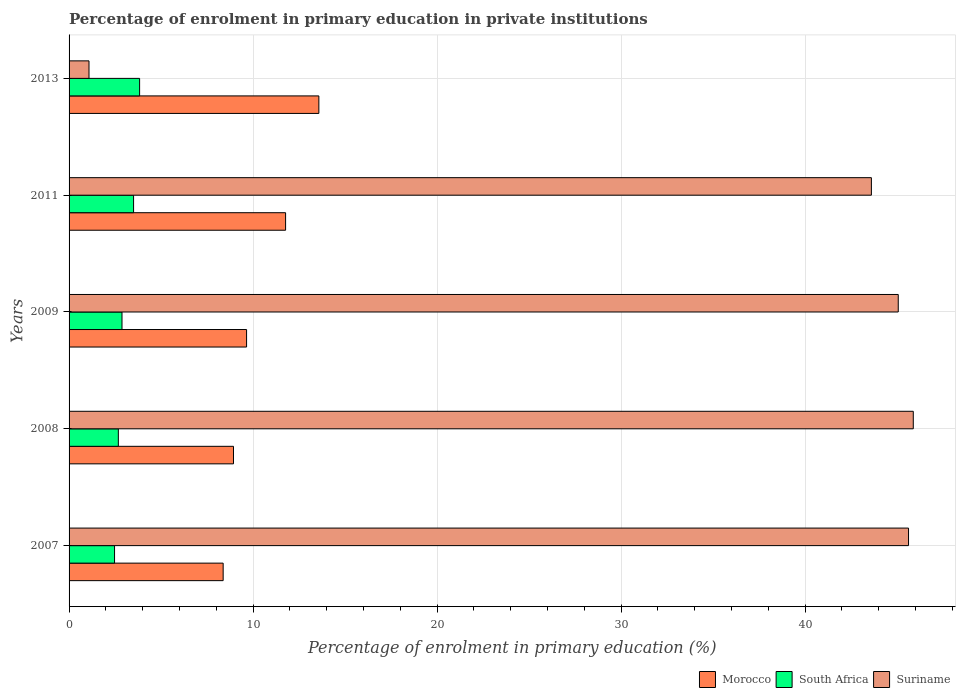Are the number of bars on each tick of the Y-axis equal?
Provide a short and direct response. Yes. How many bars are there on the 4th tick from the bottom?
Your answer should be compact. 3. What is the label of the 1st group of bars from the top?
Keep it short and to the point. 2013. What is the percentage of enrolment in primary education in Morocco in 2007?
Offer a very short reply. 8.37. Across all years, what is the maximum percentage of enrolment in primary education in Morocco?
Offer a very short reply. 13.58. Across all years, what is the minimum percentage of enrolment in primary education in South Africa?
Your answer should be compact. 2.47. What is the total percentage of enrolment in primary education in Suriname in the graph?
Keep it short and to the point. 181.26. What is the difference between the percentage of enrolment in primary education in Morocco in 2009 and that in 2013?
Ensure brevity in your answer.  -3.93. What is the difference between the percentage of enrolment in primary education in Morocco in 2007 and the percentage of enrolment in primary education in South Africa in 2013?
Offer a terse response. 4.54. What is the average percentage of enrolment in primary education in Suriname per year?
Offer a terse response. 36.25. In the year 2011, what is the difference between the percentage of enrolment in primary education in South Africa and percentage of enrolment in primary education in Morocco?
Provide a short and direct response. -8.26. What is the ratio of the percentage of enrolment in primary education in South Africa in 2011 to that in 2013?
Keep it short and to the point. 0.91. Is the percentage of enrolment in primary education in Morocco in 2007 less than that in 2011?
Offer a terse response. Yes. What is the difference between the highest and the second highest percentage of enrolment in primary education in South Africa?
Offer a very short reply. 0.33. What is the difference between the highest and the lowest percentage of enrolment in primary education in Suriname?
Offer a terse response. 44.8. Is the sum of the percentage of enrolment in primary education in Suriname in 2007 and 2011 greater than the maximum percentage of enrolment in primary education in South Africa across all years?
Provide a short and direct response. Yes. What does the 3rd bar from the top in 2013 represents?
Your response must be concise. Morocco. What does the 2nd bar from the bottom in 2007 represents?
Your answer should be compact. South Africa. What is the difference between two consecutive major ticks on the X-axis?
Provide a succinct answer. 10. Are the values on the major ticks of X-axis written in scientific E-notation?
Your response must be concise. No. Does the graph contain grids?
Offer a very short reply. Yes. How many legend labels are there?
Your answer should be compact. 3. What is the title of the graph?
Ensure brevity in your answer.  Percentage of enrolment in primary education in private institutions. What is the label or title of the X-axis?
Your answer should be very brief. Percentage of enrolment in primary education (%). What is the label or title of the Y-axis?
Your answer should be very brief. Years. What is the Percentage of enrolment in primary education (%) in Morocco in 2007?
Offer a terse response. 8.37. What is the Percentage of enrolment in primary education (%) of South Africa in 2007?
Your response must be concise. 2.47. What is the Percentage of enrolment in primary education (%) in Suriname in 2007?
Provide a succinct answer. 45.62. What is the Percentage of enrolment in primary education (%) in Morocco in 2008?
Offer a terse response. 8.94. What is the Percentage of enrolment in primary education (%) of South Africa in 2008?
Keep it short and to the point. 2.68. What is the Percentage of enrolment in primary education (%) in Suriname in 2008?
Provide a succinct answer. 45.88. What is the Percentage of enrolment in primary education (%) in Morocco in 2009?
Provide a short and direct response. 9.65. What is the Percentage of enrolment in primary education (%) in South Africa in 2009?
Your answer should be very brief. 2.88. What is the Percentage of enrolment in primary education (%) in Suriname in 2009?
Offer a terse response. 45.06. What is the Percentage of enrolment in primary education (%) of Morocco in 2011?
Your response must be concise. 11.77. What is the Percentage of enrolment in primary education (%) in South Africa in 2011?
Ensure brevity in your answer.  3.51. What is the Percentage of enrolment in primary education (%) of Suriname in 2011?
Your answer should be compact. 43.6. What is the Percentage of enrolment in primary education (%) in Morocco in 2013?
Your answer should be compact. 13.58. What is the Percentage of enrolment in primary education (%) in South Africa in 2013?
Your answer should be very brief. 3.83. What is the Percentage of enrolment in primary education (%) in Suriname in 2013?
Make the answer very short. 1.08. Across all years, what is the maximum Percentage of enrolment in primary education (%) in Morocco?
Provide a succinct answer. 13.58. Across all years, what is the maximum Percentage of enrolment in primary education (%) in South Africa?
Offer a very short reply. 3.83. Across all years, what is the maximum Percentage of enrolment in primary education (%) in Suriname?
Make the answer very short. 45.88. Across all years, what is the minimum Percentage of enrolment in primary education (%) in Morocco?
Give a very brief answer. 8.37. Across all years, what is the minimum Percentage of enrolment in primary education (%) in South Africa?
Your answer should be very brief. 2.47. Across all years, what is the minimum Percentage of enrolment in primary education (%) of Suriname?
Keep it short and to the point. 1.08. What is the total Percentage of enrolment in primary education (%) of Morocco in the graph?
Offer a very short reply. 52.3. What is the total Percentage of enrolment in primary education (%) of South Africa in the graph?
Your answer should be compact. 15.37. What is the total Percentage of enrolment in primary education (%) in Suriname in the graph?
Give a very brief answer. 181.26. What is the difference between the Percentage of enrolment in primary education (%) in Morocco in 2007 and that in 2008?
Give a very brief answer. -0.56. What is the difference between the Percentage of enrolment in primary education (%) of South Africa in 2007 and that in 2008?
Offer a terse response. -0.21. What is the difference between the Percentage of enrolment in primary education (%) of Suriname in 2007 and that in 2008?
Your answer should be compact. -0.26. What is the difference between the Percentage of enrolment in primary education (%) in Morocco in 2007 and that in 2009?
Your answer should be very brief. -1.27. What is the difference between the Percentage of enrolment in primary education (%) in South Africa in 2007 and that in 2009?
Provide a succinct answer. -0.4. What is the difference between the Percentage of enrolment in primary education (%) in Suriname in 2007 and that in 2009?
Your answer should be very brief. 0.56. What is the difference between the Percentage of enrolment in primary education (%) in Morocco in 2007 and that in 2011?
Provide a short and direct response. -3.39. What is the difference between the Percentage of enrolment in primary education (%) in South Africa in 2007 and that in 2011?
Ensure brevity in your answer.  -1.03. What is the difference between the Percentage of enrolment in primary education (%) in Suriname in 2007 and that in 2011?
Give a very brief answer. 2.02. What is the difference between the Percentage of enrolment in primary education (%) of Morocco in 2007 and that in 2013?
Your answer should be compact. -5.2. What is the difference between the Percentage of enrolment in primary education (%) of South Africa in 2007 and that in 2013?
Offer a terse response. -1.36. What is the difference between the Percentage of enrolment in primary education (%) in Suriname in 2007 and that in 2013?
Your answer should be very brief. 44.54. What is the difference between the Percentage of enrolment in primary education (%) of Morocco in 2008 and that in 2009?
Keep it short and to the point. -0.71. What is the difference between the Percentage of enrolment in primary education (%) in South Africa in 2008 and that in 2009?
Provide a short and direct response. -0.2. What is the difference between the Percentage of enrolment in primary education (%) in Suriname in 2008 and that in 2009?
Provide a short and direct response. 0.82. What is the difference between the Percentage of enrolment in primary education (%) of Morocco in 2008 and that in 2011?
Your answer should be very brief. -2.83. What is the difference between the Percentage of enrolment in primary education (%) of South Africa in 2008 and that in 2011?
Give a very brief answer. -0.83. What is the difference between the Percentage of enrolment in primary education (%) of Suriname in 2008 and that in 2011?
Ensure brevity in your answer.  2.28. What is the difference between the Percentage of enrolment in primary education (%) of Morocco in 2008 and that in 2013?
Ensure brevity in your answer.  -4.64. What is the difference between the Percentage of enrolment in primary education (%) in South Africa in 2008 and that in 2013?
Keep it short and to the point. -1.16. What is the difference between the Percentage of enrolment in primary education (%) of Suriname in 2008 and that in 2013?
Offer a very short reply. 44.8. What is the difference between the Percentage of enrolment in primary education (%) in Morocco in 2009 and that in 2011?
Offer a terse response. -2.12. What is the difference between the Percentage of enrolment in primary education (%) in South Africa in 2009 and that in 2011?
Offer a terse response. -0.63. What is the difference between the Percentage of enrolment in primary education (%) in Suriname in 2009 and that in 2011?
Ensure brevity in your answer.  1.46. What is the difference between the Percentage of enrolment in primary education (%) in Morocco in 2009 and that in 2013?
Your answer should be compact. -3.93. What is the difference between the Percentage of enrolment in primary education (%) of South Africa in 2009 and that in 2013?
Make the answer very short. -0.96. What is the difference between the Percentage of enrolment in primary education (%) of Suriname in 2009 and that in 2013?
Your answer should be very brief. 43.98. What is the difference between the Percentage of enrolment in primary education (%) of Morocco in 2011 and that in 2013?
Ensure brevity in your answer.  -1.81. What is the difference between the Percentage of enrolment in primary education (%) of South Africa in 2011 and that in 2013?
Your answer should be very brief. -0.33. What is the difference between the Percentage of enrolment in primary education (%) in Suriname in 2011 and that in 2013?
Offer a very short reply. 42.52. What is the difference between the Percentage of enrolment in primary education (%) of Morocco in 2007 and the Percentage of enrolment in primary education (%) of South Africa in 2008?
Keep it short and to the point. 5.7. What is the difference between the Percentage of enrolment in primary education (%) of Morocco in 2007 and the Percentage of enrolment in primary education (%) of Suriname in 2008?
Your answer should be compact. -37.51. What is the difference between the Percentage of enrolment in primary education (%) in South Africa in 2007 and the Percentage of enrolment in primary education (%) in Suriname in 2008?
Ensure brevity in your answer.  -43.41. What is the difference between the Percentage of enrolment in primary education (%) in Morocco in 2007 and the Percentage of enrolment in primary education (%) in South Africa in 2009?
Your response must be concise. 5.5. What is the difference between the Percentage of enrolment in primary education (%) of Morocco in 2007 and the Percentage of enrolment in primary education (%) of Suriname in 2009?
Make the answer very short. -36.69. What is the difference between the Percentage of enrolment in primary education (%) in South Africa in 2007 and the Percentage of enrolment in primary education (%) in Suriname in 2009?
Make the answer very short. -42.59. What is the difference between the Percentage of enrolment in primary education (%) in Morocco in 2007 and the Percentage of enrolment in primary education (%) in South Africa in 2011?
Your response must be concise. 4.87. What is the difference between the Percentage of enrolment in primary education (%) of Morocco in 2007 and the Percentage of enrolment in primary education (%) of Suriname in 2011?
Ensure brevity in your answer.  -35.23. What is the difference between the Percentage of enrolment in primary education (%) in South Africa in 2007 and the Percentage of enrolment in primary education (%) in Suriname in 2011?
Give a very brief answer. -41.13. What is the difference between the Percentage of enrolment in primary education (%) in Morocco in 2007 and the Percentage of enrolment in primary education (%) in South Africa in 2013?
Make the answer very short. 4.54. What is the difference between the Percentage of enrolment in primary education (%) of Morocco in 2007 and the Percentage of enrolment in primary education (%) of Suriname in 2013?
Your response must be concise. 7.29. What is the difference between the Percentage of enrolment in primary education (%) of South Africa in 2007 and the Percentage of enrolment in primary education (%) of Suriname in 2013?
Give a very brief answer. 1.39. What is the difference between the Percentage of enrolment in primary education (%) in Morocco in 2008 and the Percentage of enrolment in primary education (%) in South Africa in 2009?
Offer a very short reply. 6.06. What is the difference between the Percentage of enrolment in primary education (%) in Morocco in 2008 and the Percentage of enrolment in primary education (%) in Suriname in 2009?
Make the answer very short. -36.13. What is the difference between the Percentage of enrolment in primary education (%) in South Africa in 2008 and the Percentage of enrolment in primary education (%) in Suriname in 2009?
Provide a succinct answer. -42.39. What is the difference between the Percentage of enrolment in primary education (%) in Morocco in 2008 and the Percentage of enrolment in primary education (%) in South Africa in 2011?
Provide a short and direct response. 5.43. What is the difference between the Percentage of enrolment in primary education (%) in Morocco in 2008 and the Percentage of enrolment in primary education (%) in Suriname in 2011?
Make the answer very short. -34.67. What is the difference between the Percentage of enrolment in primary education (%) in South Africa in 2008 and the Percentage of enrolment in primary education (%) in Suriname in 2011?
Provide a short and direct response. -40.93. What is the difference between the Percentage of enrolment in primary education (%) in Morocco in 2008 and the Percentage of enrolment in primary education (%) in South Africa in 2013?
Keep it short and to the point. 5.1. What is the difference between the Percentage of enrolment in primary education (%) in Morocco in 2008 and the Percentage of enrolment in primary education (%) in Suriname in 2013?
Your answer should be very brief. 7.85. What is the difference between the Percentage of enrolment in primary education (%) of South Africa in 2008 and the Percentage of enrolment in primary education (%) of Suriname in 2013?
Provide a succinct answer. 1.59. What is the difference between the Percentage of enrolment in primary education (%) of Morocco in 2009 and the Percentage of enrolment in primary education (%) of South Africa in 2011?
Make the answer very short. 6.14. What is the difference between the Percentage of enrolment in primary education (%) of Morocco in 2009 and the Percentage of enrolment in primary education (%) of Suriname in 2011?
Offer a very short reply. -33.96. What is the difference between the Percentage of enrolment in primary education (%) of South Africa in 2009 and the Percentage of enrolment in primary education (%) of Suriname in 2011?
Offer a terse response. -40.73. What is the difference between the Percentage of enrolment in primary education (%) of Morocco in 2009 and the Percentage of enrolment in primary education (%) of South Africa in 2013?
Ensure brevity in your answer.  5.81. What is the difference between the Percentage of enrolment in primary education (%) in Morocco in 2009 and the Percentage of enrolment in primary education (%) in Suriname in 2013?
Offer a terse response. 8.56. What is the difference between the Percentage of enrolment in primary education (%) in South Africa in 2009 and the Percentage of enrolment in primary education (%) in Suriname in 2013?
Your response must be concise. 1.79. What is the difference between the Percentage of enrolment in primary education (%) of Morocco in 2011 and the Percentage of enrolment in primary education (%) of South Africa in 2013?
Give a very brief answer. 7.93. What is the difference between the Percentage of enrolment in primary education (%) in Morocco in 2011 and the Percentage of enrolment in primary education (%) in Suriname in 2013?
Your answer should be very brief. 10.68. What is the difference between the Percentage of enrolment in primary education (%) of South Africa in 2011 and the Percentage of enrolment in primary education (%) of Suriname in 2013?
Keep it short and to the point. 2.42. What is the average Percentage of enrolment in primary education (%) in Morocco per year?
Ensure brevity in your answer.  10.46. What is the average Percentage of enrolment in primary education (%) in South Africa per year?
Offer a terse response. 3.07. What is the average Percentage of enrolment in primary education (%) in Suriname per year?
Your answer should be compact. 36.25. In the year 2007, what is the difference between the Percentage of enrolment in primary education (%) of Morocco and Percentage of enrolment in primary education (%) of South Africa?
Provide a short and direct response. 5.9. In the year 2007, what is the difference between the Percentage of enrolment in primary education (%) in Morocco and Percentage of enrolment in primary education (%) in Suriname?
Offer a terse response. -37.25. In the year 2007, what is the difference between the Percentage of enrolment in primary education (%) in South Africa and Percentage of enrolment in primary education (%) in Suriname?
Your answer should be very brief. -43.15. In the year 2008, what is the difference between the Percentage of enrolment in primary education (%) in Morocco and Percentage of enrolment in primary education (%) in South Africa?
Provide a short and direct response. 6.26. In the year 2008, what is the difference between the Percentage of enrolment in primary education (%) of Morocco and Percentage of enrolment in primary education (%) of Suriname?
Give a very brief answer. -36.95. In the year 2008, what is the difference between the Percentage of enrolment in primary education (%) of South Africa and Percentage of enrolment in primary education (%) of Suriname?
Keep it short and to the point. -43.2. In the year 2009, what is the difference between the Percentage of enrolment in primary education (%) of Morocco and Percentage of enrolment in primary education (%) of South Africa?
Your answer should be compact. 6.77. In the year 2009, what is the difference between the Percentage of enrolment in primary education (%) in Morocco and Percentage of enrolment in primary education (%) in Suriname?
Give a very brief answer. -35.42. In the year 2009, what is the difference between the Percentage of enrolment in primary education (%) of South Africa and Percentage of enrolment in primary education (%) of Suriname?
Keep it short and to the point. -42.19. In the year 2011, what is the difference between the Percentage of enrolment in primary education (%) in Morocco and Percentage of enrolment in primary education (%) in South Africa?
Provide a short and direct response. 8.26. In the year 2011, what is the difference between the Percentage of enrolment in primary education (%) in Morocco and Percentage of enrolment in primary education (%) in Suriname?
Offer a terse response. -31.84. In the year 2011, what is the difference between the Percentage of enrolment in primary education (%) of South Africa and Percentage of enrolment in primary education (%) of Suriname?
Your answer should be very brief. -40.1. In the year 2013, what is the difference between the Percentage of enrolment in primary education (%) of Morocco and Percentage of enrolment in primary education (%) of South Africa?
Ensure brevity in your answer.  9.74. In the year 2013, what is the difference between the Percentage of enrolment in primary education (%) in Morocco and Percentage of enrolment in primary education (%) in Suriname?
Give a very brief answer. 12.49. In the year 2013, what is the difference between the Percentage of enrolment in primary education (%) of South Africa and Percentage of enrolment in primary education (%) of Suriname?
Your answer should be compact. 2.75. What is the ratio of the Percentage of enrolment in primary education (%) in Morocco in 2007 to that in 2008?
Offer a terse response. 0.94. What is the ratio of the Percentage of enrolment in primary education (%) in South Africa in 2007 to that in 2008?
Your answer should be very brief. 0.92. What is the ratio of the Percentage of enrolment in primary education (%) in Suriname in 2007 to that in 2008?
Give a very brief answer. 0.99. What is the ratio of the Percentage of enrolment in primary education (%) in Morocco in 2007 to that in 2009?
Keep it short and to the point. 0.87. What is the ratio of the Percentage of enrolment in primary education (%) of South Africa in 2007 to that in 2009?
Your response must be concise. 0.86. What is the ratio of the Percentage of enrolment in primary education (%) of Suriname in 2007 to that in 2009?
Provide a succinct answer. 1.01. What is the ratio of the Percentage of enrolment in primary education (%) in Morocco in 2007 to that in 2011?
Your answer should be very brief. 0.71. What is the ratio of the Percentage of enrolment in primary education (%) in South Africa in 2007 to that in 2011?
Make the answer very short. 0.7. What is the ratio of the Percentage of enrolment in primary education (%) of Suriname in 2007 to that in 2011?
Provide a short and direct response. 1.05. What is the ratio of the Percentage of enrolment in primary education (%) in Morocco in 2007 to that in 2013?
Your response must be concise. 0.62. What is the ratio of the Percentage of enrolment in primary education (%) of South Africa in 2007 to that in 2013?
Provide a short and direct response. 0.64. What is the ratio of the Percentage of enrolment in primary education (%) of Suriname in 2007 to that in 2013?
Offer a terse response. 42.11. What is the ratio of the Percentage of enrolment in primary education (%) in Morocco in 2008 to that in 2009?
Provide a succinct answer. 0.93. What is the ratio of the Percentage of enrolment in primary education (%) of South Africa in 2008 to that in 2009?
Your answer should be very brief. 0.93. What is the ratio of the Percentage of enrolment in primary education (%) in Suriname in 2008 to that in 2009?
Provide a short and direct response. 1.02. What is the ratio of the Percentage of enrolment in primary education (%) of Morocco in 2008 to that in 2011?
Your answer should be compact. 0.76. What is the ratio of the Percentage of enrolment in primary education (%) of South Africa in 2008 to that in 2011?
Offer a terse response. 0.76. What is the ratio of the Percentage of enrolment in primary education (%) of Suriname in 2008 to that in 2011?
Make the answer very short. 1.05. What is the ratio of the Percentage of enrolment in primary education (%) in Morocco in 2008 to that in 2013?
Provide a short and direct response. 0.66. What is the ratio of the Percentage of enrolment in primary education (%) in South Africa in 2008 to that in 2013?
Ensure brevity in your answer.  0.7. What is the ratio of the Percentage of enrolment in primary education (%) in Suriname in 2008 to that in 2013?
Ensure brevity in your answer.  42.35. What is the ratio of the Percentage of enrolment in primary education (%) in Morocco in 2009 to that in 2011?
Ensure brevity in your answer.  0.82. What is the ratio of the Percentage of enrolment in primary education (%) of South Africa in 2009 to that in 2011?
Your answer should be compact. 0.82. What is the ratio of the Percentage of enrolment in primary education (%) of Suriname in 2009 to that in 2011?
Make the answer very short. 1.03. What is the ratio of the Percentage of enrolment in primary education (%) of Morocco in 2009 to that in 2013?
Your answer should be compact. 0.71. What is the ratio of the Percentage of enrolment in primary education (%) of South Africa in 2009 to that in 2013?
Give a very brief answer. 0.75. What is the ratio of the Percentage of enrolment in primary education (%) in Suriname in 2009 to that in 2013?
Your answer should be compact. 41.59. What is the ratio of the Percentage of enrolment in primary education (%) in Morocco in 2011 to that in 2013?
Your response must be concise. 0.87. What is the ratio of the Percentage of enrolment in primary education (%) in South Africa in 2011 to that in 2013?
Offer a very short reply. 0.91. What is the ratio of the Percentage of enrolment in primary education (%) of Suriname in 2011 to that in 2013?
Provide a short and direct response. 40.25. What is the difference between the highest and the second highest Percentage of enrolment in primary education (%) in Morocco?
Offer a terse response. 1.81. What is the difference between the highest and the second highest Percentage of enrolment in primary education (%) in South Africa?
Offer a very short reply. 0.33. What is the difference between the highest and the second highest Percentage of enrolment in primary education (%) in Suriname?
Give a very brief answer. 0.26. What is the difference between the highest and the lowest Percentage of enrolment in primary education (%) of Morocco?
Your answer should be compact. 5.2. What is the difference between the highest and the lowest Percentage of enrolment in primary education (%) of South Africa?
Your response must be concise. 1.36. What is the difference between the highest and the lowest Percentage of enrolment in primary education (%) in Suriname?
Your response must be concise. 44.8. 